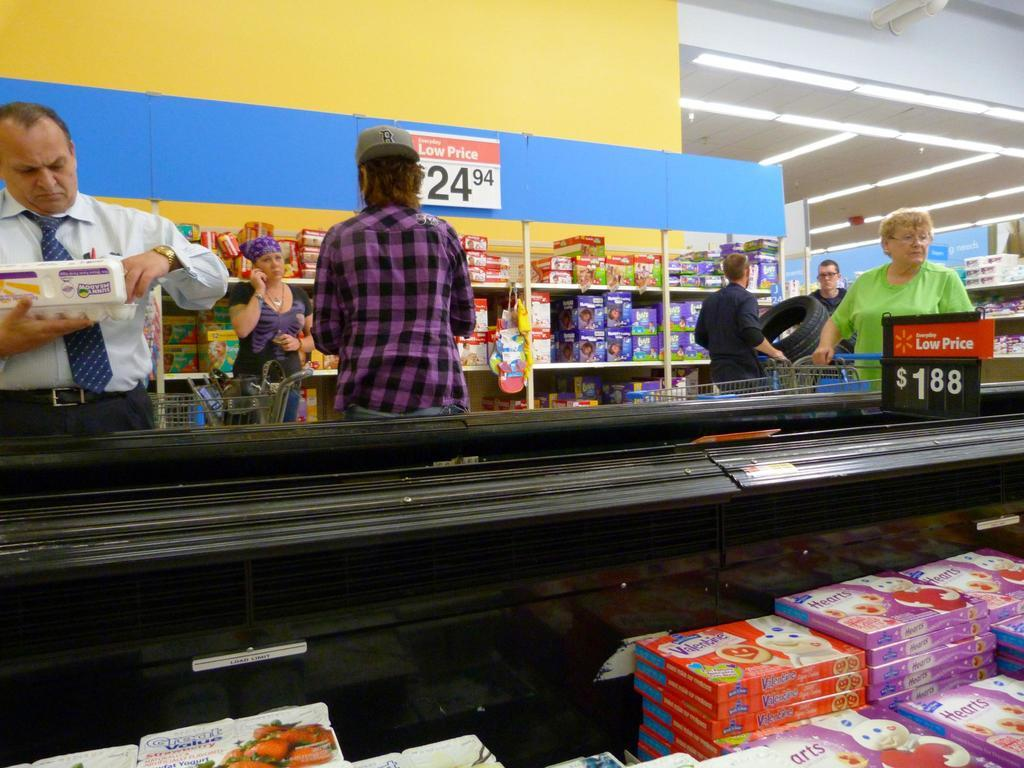<image>
Present a compact description of the photo's key features. The inside of a grocery store with some Pillsbury Pizza product in the freezer. 